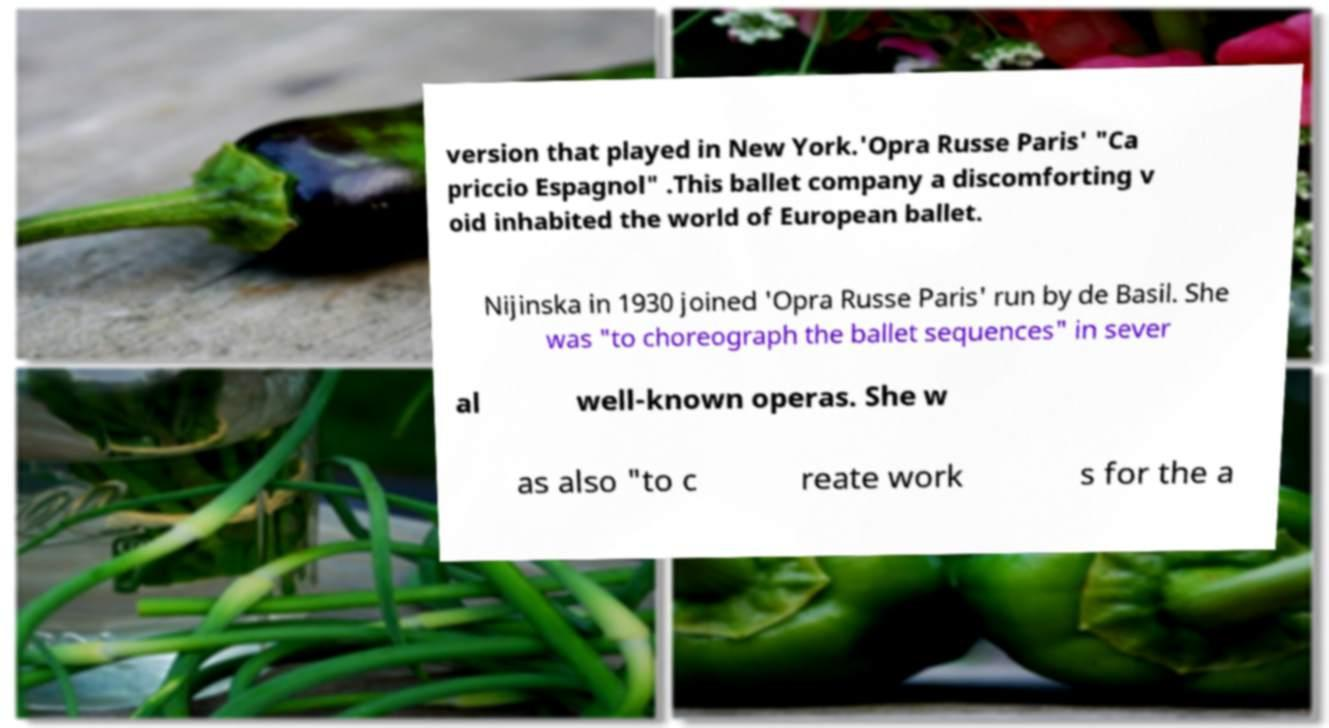I need the written content from this picture converted into text. Can you do that? version that played in New York.'Opra Russe Paris' "Ca priccio Espagnol" .This ballet company a discomforting v oid inhabited the world of European ballet. Nijinska in 1930 joined 'Opra Russe Paris' run by de Basil. She was "to choreograph the ballet sequences" in sever al well-known operas. She w as also "to c reate work s for the a 